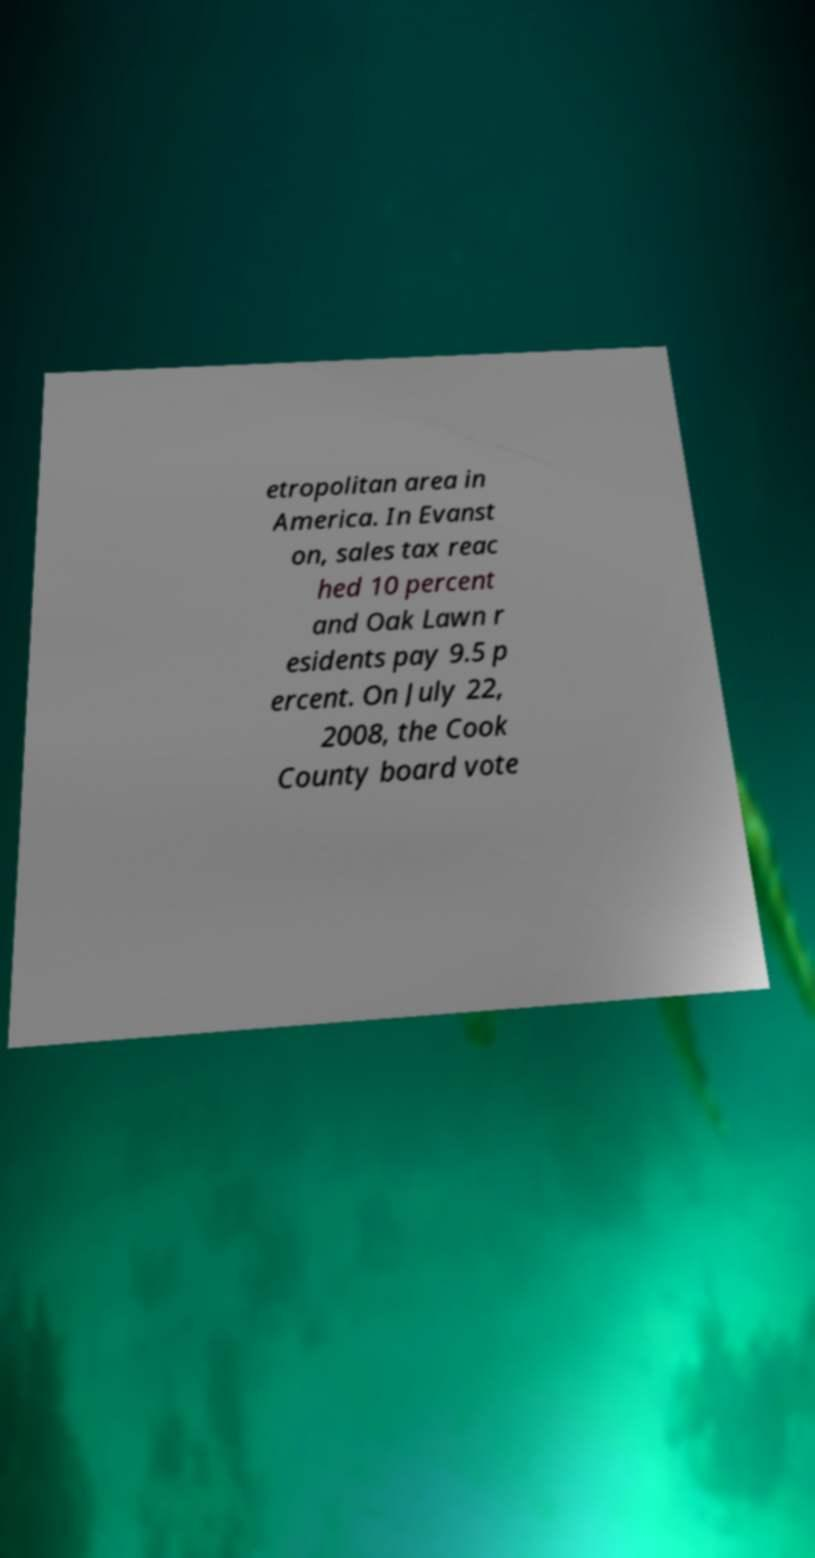Can you accurately transcribe the text from the provided image for me? etropolitan area in America. In Evanst on, sales tax reac hed 10 percent and Oak Lawn r esidents pay 9.5 p ercent. On July 22, 2008, the Cook County board vote 